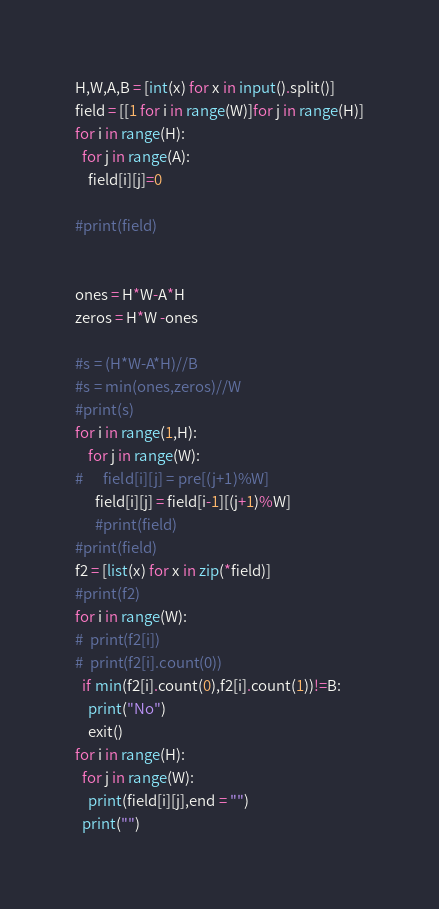Convert code to text. <code><loc_0><loc_0><loc_500><loc_500><_Python_>H,W,A,B = [int(x) for x in input().split()]
field = [[1 for i in range(W)]for j in range(H)]
for i in range(H):
  for j in range(A):
    field[i][j]=0

#print(field)


ones = H*W-A*H
zeros = H*W -ones

#s = (H*W-A*H)//B
#s = min(ones,zeros)//W
#print(s)
for i in range(1,H):
    for j in range(W):
#      field[i][j] = pre[(j+1)%W]
      field[i][j] = field[i-1][(j+1)%W]
      #print(field)
#print(field)
f2 = [list(x) for x in zip(*field)]
#print(f2)
for i in range(W):
#  print(f2[i])
#  print(f2[i].count(0))
  if min(f2[i].count(0),f2[i].count(1))!=B:
    print("No")
    exit()
for i in range(H):
  for j in range(W):
    print(field[i][j],end = "")
  print("")</code> 